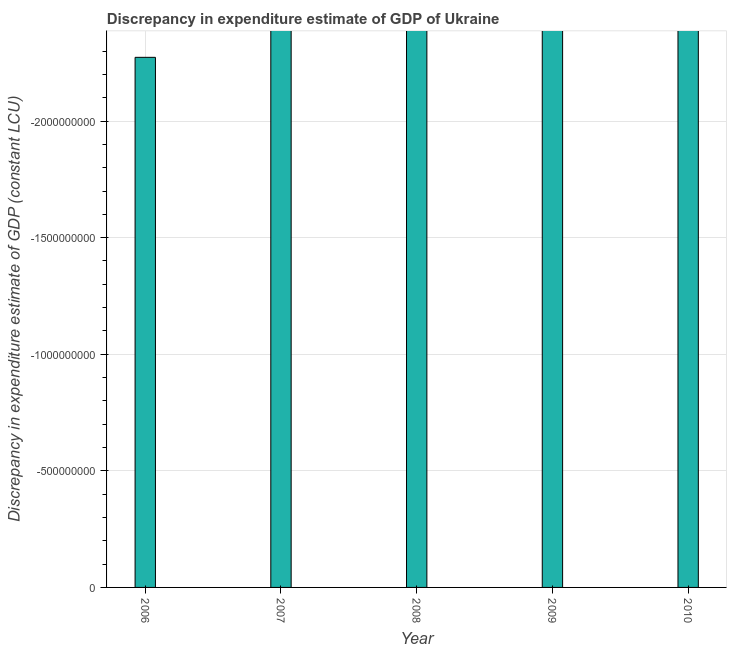Does the graph contain any zero values?
Ensure brevity in your answer.  Yes. What is the title of the graph?
Keep it short and to the point. Discrepancy in expenditure estimate of GDP of Ukraine. What is the label or title of the Y-axis?
Give a very brief answer. Discrepancy in expenditure estimate of GDP (constant LCU). What is the average discrepancy in expenditure estimate of gdp per year?
Give a very brief answer. 0. In how many years, is the discrepancy in expenditure estimate of gdp greater than the average discrepancy in expenditure estimate of gdp taken over all years?
Offer a terse response. 0. How many years are there in the graph?
Provide a succinct answer. 5. What is the difference between two consecutive major ticks on the Y-axis?
Give a very brief answer. 5.00e+08. What is the Discrepancy in expenditure estimate of GDP (constant LCU) of 2007?
Your answer should be very brief. 0. What is the Discrepancy in expenditure estimate of GDP (constant LCU) of 2008?
Your answer should be compact. 0. What is the Discrepancy in expenditure estimate of GDP (constant LCU) of 2009?
Offer a very short reply. 0. 